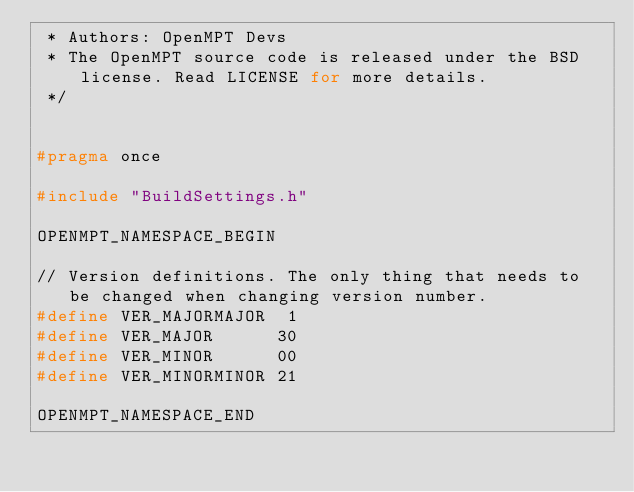Convert code to text. <code><loc_0><loc_0><loc_500><loc_500><_C_> * Authors: OpenMPT Devs
 * The OpenMPT source code is released under the BSD license. Read LICENSE for more details.
 */


#pragma once

#include "BuildSettings.h"

OPENMPT_NAMESPACE_BEGIN

// Version definitions. The only thing that needs to be changed when changing version number.
#define VER_MAJORMAJOR  1
#define VER_MAJOR      30
#define VER_MINOR      00
#define VER_MINORMINOR 21

OPENMPT_NAMESPACE_END
</code> 